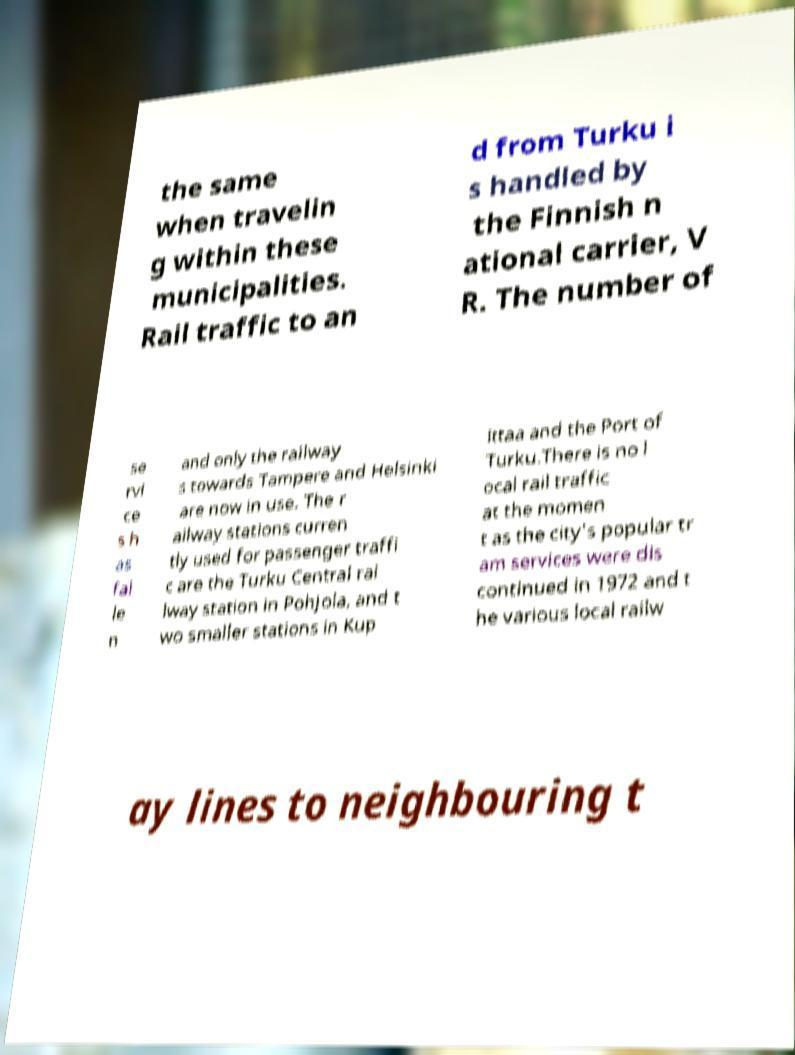What messages or text are displayed in this image? I need them in a readable, typed format. the same when travelin g within these municipalities. Rail traffic to an d from Turku i s handled by the Finnish n ational carrier, V R. The number of se rvi ce s h as fal le n and only the railway s towards Tampere and Helsinki are now in use. The r ailway stations curren tly used for passenger traffi c are the Turku Central rai lway station in Pohjola, and t wo smaller stations in Kup ittaa and the Port of Turku.There is no l ocal rail traffic at the momen t as the city's popular tr am services were dis continued in 1972 and t he various local railw ay lines to neighbouring t 